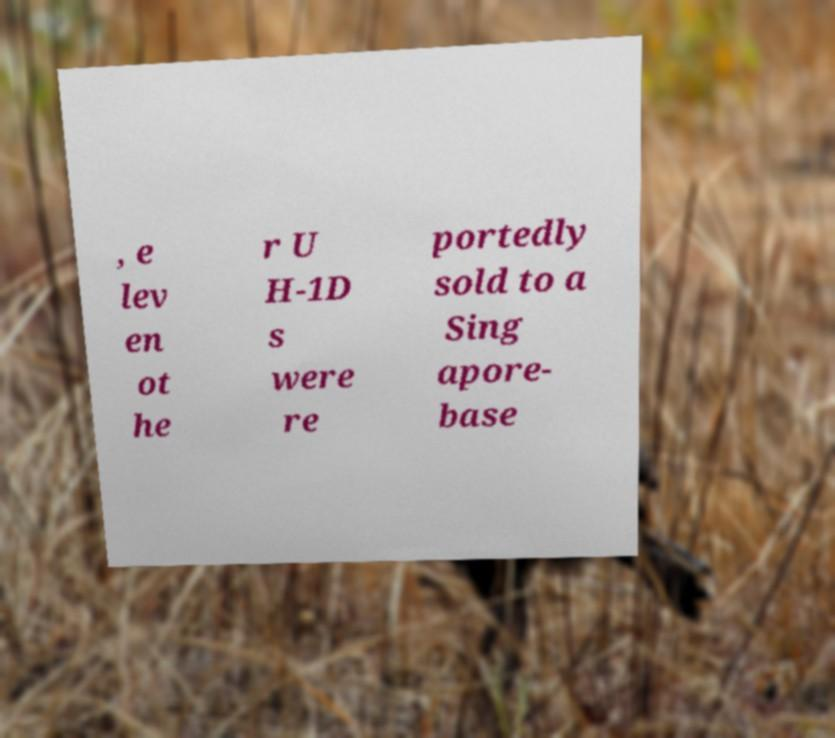Please identify and transcribe the text found in this image. , e lev en ot he r U H-1D s were re portedly sold to a Sing apore- base 